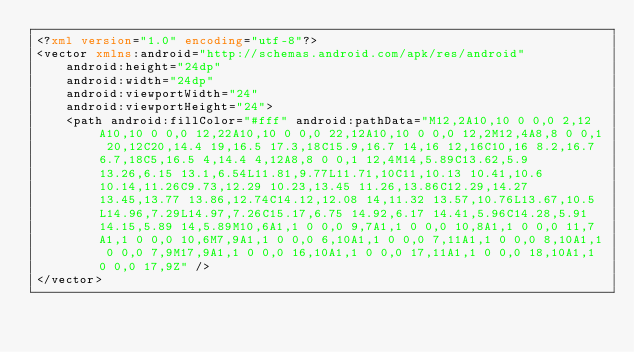<code> <loc_0><loc_0><loc_500><loc_500><_XML_><?xml version="1.0" encoding="utf-8"?>
<vector xmlns:android="http://schemas.android.com/apk/res/android"
    android:height="24dp"
    android:width="24dp"
    android:viewportWidth="24"
    android:viewportHeight="24">
    <path android:fillColor="#fff" android:pathData="M12,2A10,10 0 0,0 2,12A10,10 0 0,0 12,22A10,10 0 0,0 22,12A10,10 0 0,0 12,2M12,4A8,8 0 0,1 20,12C20,14.4 19,16.5 17.3,18C15.9,16.7 14,16 12,16C10,16 8.2,16.7 6.7,18C5,16.5 4,14.4 4,12A8,8 0 0,1 12,4M14,5.89C13.62,5.9 13.26,6.15 13.1,6.54L11.81,9.77L11.71,10C11,10.13 10.41,10.6 10.14,11.26C9.73,12.29 10.23,13.45 11.26,13.86C12.29,14.27 13.45,13.77 13.86,12.74C14.12,12.08 14,11.32 13.57,10.76L13.67,10.5L14.96,7.29L14.97,7.26C15.17,6.75 14.92,6.17 14.41,5.96C14.28,5.91 14.15,5.89 14,5.89M10,6A1,1 0 0,0 9,7A1,1 0 0,0 10,8A1,1 0 0,0 11,7A1,1 0 0,0 10,6M7,9A1,1 0 0,0 6,10A1,1 0 0,0 7,11A1,1 0 0,0 8,10A1,1 0 0,0 7,9M17,9A1,1 0 0,0 16,10A1,1 0 0,0 17,11A1,1 0 0,0 18,10A1,1 0 0,0 17,9Z" />
</vector></code> 